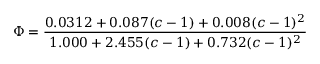<formula> <loc_0><loc_0><loc_500><loc_500>\Phi = { \frac { 0 . 0 3 1 2 + 0 . 0 8 7 ( c - 1 ) + 0 . 0 0 8 ( c - 1 ) ^ { 2 } } { 1 . 0 0 0 + 2 . 4 5 5 ( c - 1 ) + 0 . 7 3 2 ( c - 1 ) ^ { 2 } } }</formula> 